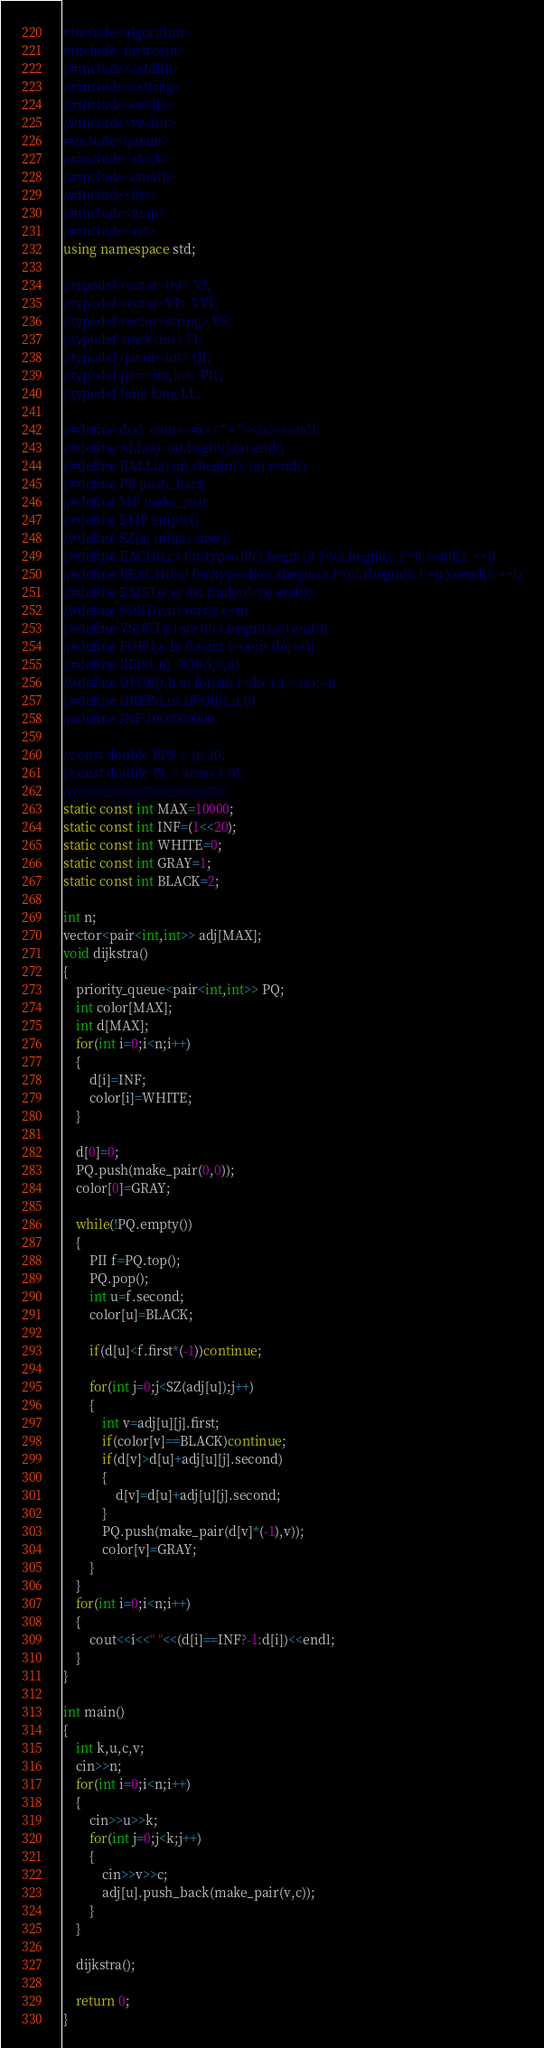<code> <loc_0><loc_0><loc_500><loc_500><_C++_>#include<algorithm>
#include<iostream>
//#include<cstdlib>
//#include<cstring>
//#include<cstdio>
//#include<vector>
#include<queue>
//#include<stack>
//#include<cmath>
//#include<list>
//#include<map>
//#include<set>
using namespace std;

//typedef vector<int> VI;
//typedef vector<VI> VVI;
//typedef vector<string> VS;
//typedef stack<int> SI;
//typedef queue<int> QI;
//typedef pair<int,int> PII;
//typedef long long LL;

//#define d(x)  cout<<#x<<" = "<<(x)<<endl;
//#define ALL(a)  (a).begin(),(a).end()
//#define RALL(a) (a).rbegin(), (a).rend()
//#define PB push_back
//#define MP make_pair
//#define EMP empty()
//#define SZ(a) int((a).size())
//#define EACH(i,c) for(typeof((c).begin()) i=(c).begin(); i!=(c).end(); ++i)
//#define REACH(i,c) for(typeof((c).rbegin()) i=(c).rbegin(); i!=(c).rend(); ++i)
//#define EXIST(s,e) ((s).find(e)!=(s).end())
//#define SORT(c,n) sort(c,c+n)
//#define VSORT(c) sort((c).begin(),(c).end())
//#define FOR(i,a,b) for(int i=(a);i<(b);++i)
//#define REP(i,n)  FOR(i,0,n)
//#define DFOR(i,b,a) for(int i=(b)-1;i>=(a);--i)
//#define DREP(i,n) DFOR(i,n,0)
//#define INF 1000000000

//const double EPS = 1e-10;
//const double PI  = acos(-1.0);
////////////////////////////////////////////////
static const int MAX=10000;
static const int INF=(1<<20);
static const int WHITE=0;
static const int GRAY=1;
static const int BLACK=2;

int n;
vector<pair<int,int>> adj[MAX];
void dijkstra()
{
	priority_queue<pair<int,int>> PQ;
	int color[MAX];
	int d[MAX];
	for(int i=0;i<n;i++)
	{
		d[i]=INF;
		color[i]=WHITE;
	}
	
	d[0]=0;
	PQ.push(make_pair(0,0));
	color[0]=GRAY;
	
	while(!PQ.empty())
	{
		PII f=PQ.top();
		PQ.pop();
		int u=f.second;
		color[u]=BLACK;
		
		if(d[u]<f.first*(-1))continue;
		
		for(int j=0;j<SZ(adj[u]);j++)
		{
			int v=adj[u][j].first;
			if(color[v]==BLACK)continue;
			if(d[v]>d[u]+adj[u][j].second)
			{
				d[v]=d[u]+adj[u][j].second;
			}
			PQ.push(make_pair(d[v]*(-1),v));
			color[v]=GRAY;
		}
	}
	for(int i=0;i<n;i++)
	{
		cout<<i<<" "<<(d[i]==INF?-1:d[i])<<endl;
	}
}

int main()
{
	int k,u,c,v;
	cin>>n;
	for(int i=0;i<n;i++)
	{
		cin>>u>>k;
		for(int j=0;j<k;j++)
		{
			cin>>v>>c;
			adj[u].push_back(make_pair(v,c));
		}
	}
	
	dijkstra();
	
	return 0;
}</code> 